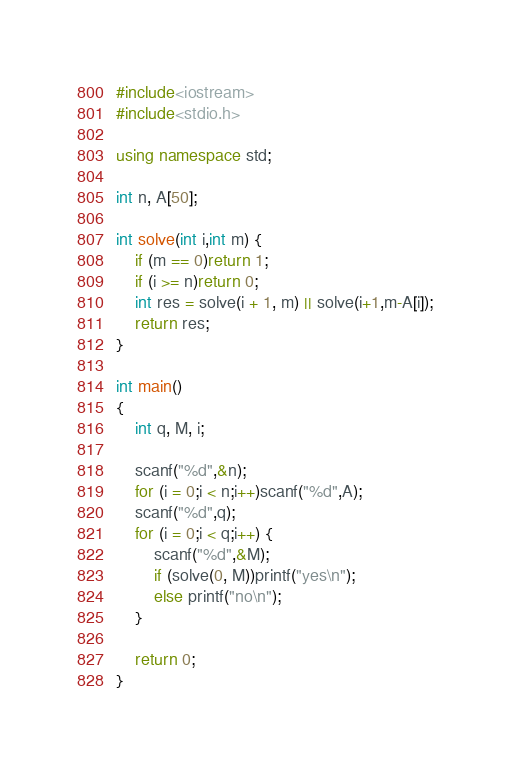Convert code to text. <code><loc_0><loc_0><loc_500><loc_500><_C++_>#include<iostream>
#include<stdio.h>

using namespace std;

int n, A[50];

int solve(int i,int m) {
	if (m == 0)return 1;
	if (i >= n)return 0;
	int res = solve(i + 1, m) || solve(i+1,m-A[i]);
	return res;
}

int main()
{
	int q, M, i;

	scanf("%d",&n);
	for (i = 0;i < n;i++)scanf("%d",A);
	scanf("%d",q);
	for (i = 0;i < q;i++) {
		scanf("%d",&M);
		if (solve(0, M))printf("yes\n");
		else printf("no\n");
	}

    return 0;
}
</code> 